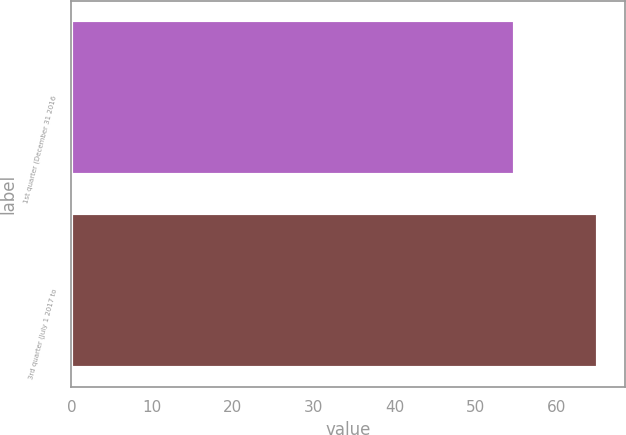Convert chart to OTSL. <chart><loc_0><loc_0><loc_500><loc_500><bar_chart><fcel>1st quarter (December 31 2016<fcel>3rd quarter (July 1 2017 to<nl><fcel>54.87<fcel>65.22<nl></chart> 